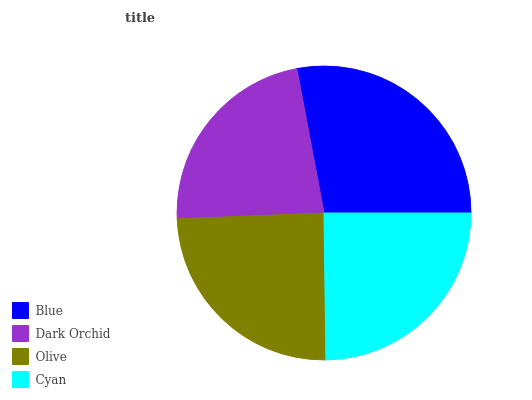Is Dark Orchid the minimum?
Answer yes or no. Yes. Is Blue the maximum?
Answer yes or no. Yes. Is Olive the minimum?
Answer yes or no. No. Is Olive the maximum?
Answer yes or no. No. Is Olive greater than Dark Orchid?
Answer yes or no. Yes. Is Dark Orchid less than Olive?
Answer yes or no. Yes. Is Dark Orchid greater than Olive?
Answer yes or no. No. Is Olive less than Dark Orchid?
Answer yes or no. No. Is Cyan the high median?
Answer yes or no. Yes. Is Olive the low median?
Answer yes or no. Yes. Is Blue the high median?
Answer yes or no. No. Is Blue the low median?
Answer yes or no. No. 